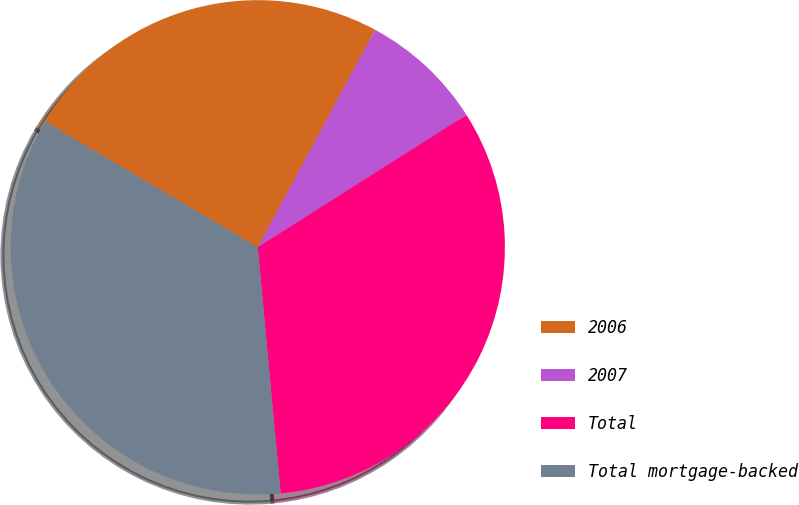<chart> <loc_0><loc_0><loc_500><loc_500><pie_chart><fcel>2006<fcel>2007<fcel>Total<fcel>Total mortgage-backed<nl><fcel>24.39%<fcel>8.13%<fcel>32.52%<fcel>34.96%<nl></chart> 